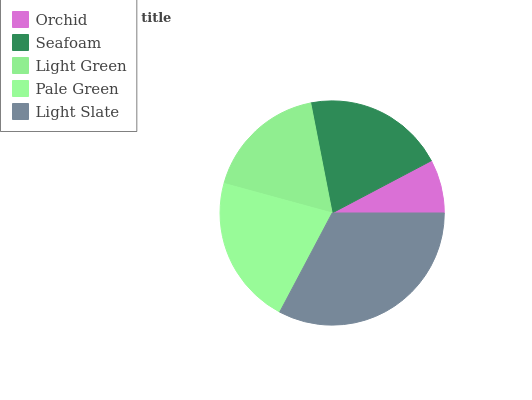Is Orchid the minimum?
Answer yes or no. Yes. Is Light Slate the maximum?
Answer yes or no. Yes. Is Seafoam the minimum?
Answer yes or no. No. Is Seafoam the maximum?
Answer yes or no. No. Is Seafoam greater than Orchid?
Answer yes or no. Yes. Is Orchid less than Seafoam?
Answer yes or no. Yes. Is Orchid greater than Seafoam?
Answer yes or no. No. Is Seafoam less than Orchid?
Answer yes or no. No. Is Seafoam the high median?
Answer yes or no. Yes. Is Seafoam the low median?
Answer yes or no. Yes. Is Light Slate the high median?
Answer yes or no. No. Is Pale Green the low median?
Answer yes or no. No. 